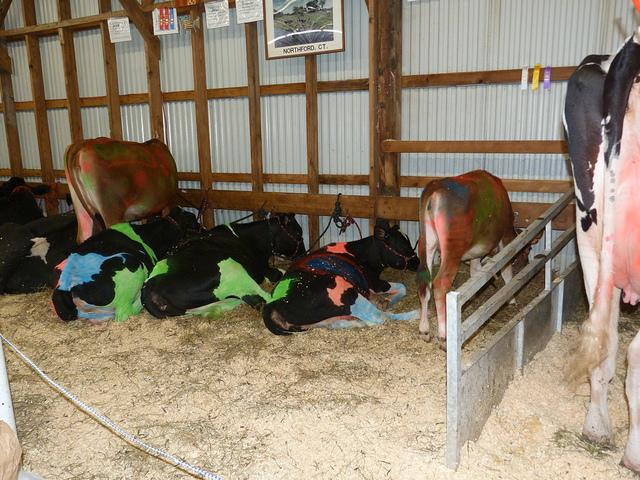What made the cows unnatural colors? Please explain your reasoning. spray paint. They paint them to designate health status 